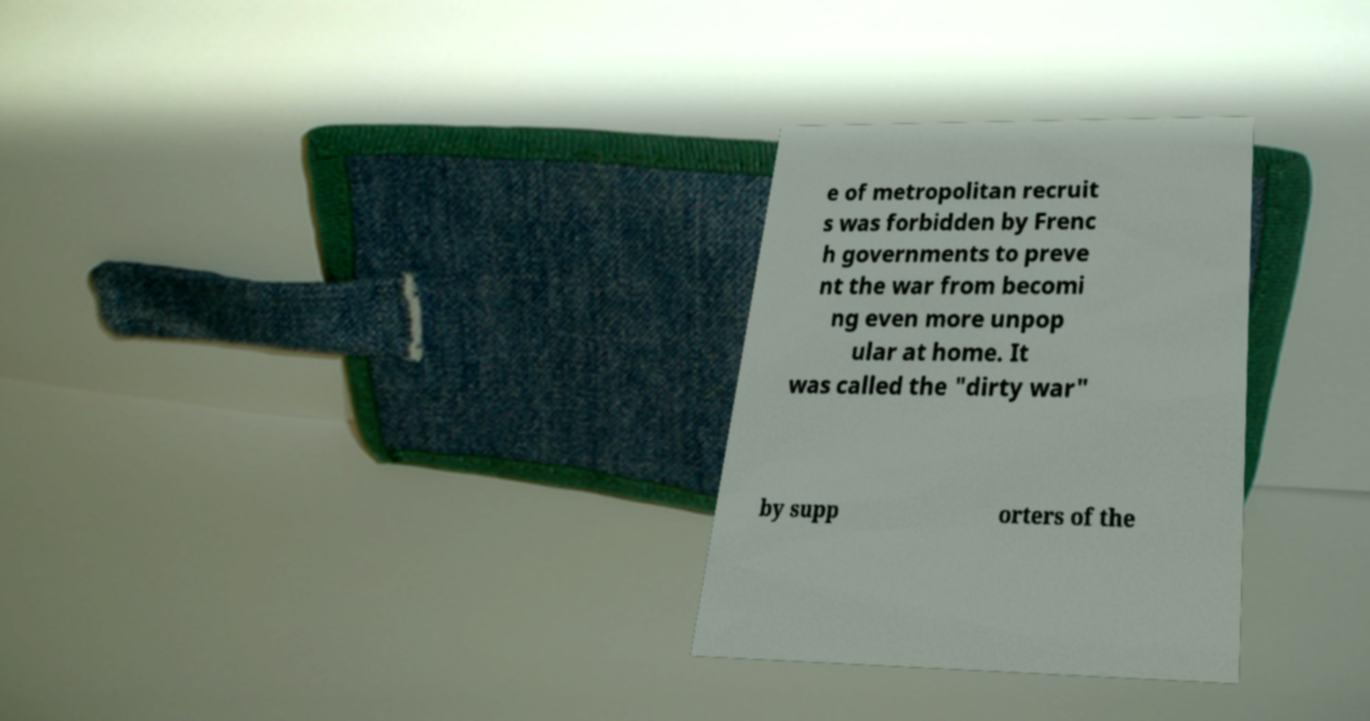There's text embedded in this image that I need extracted. Can you transcribe it verbatim? e of metropolitan recruit s was forbidden by Frenc h governments to preve nt the war from becomi ng even more unpop ular at home. It was called the "dirty war" by supp orters of the 